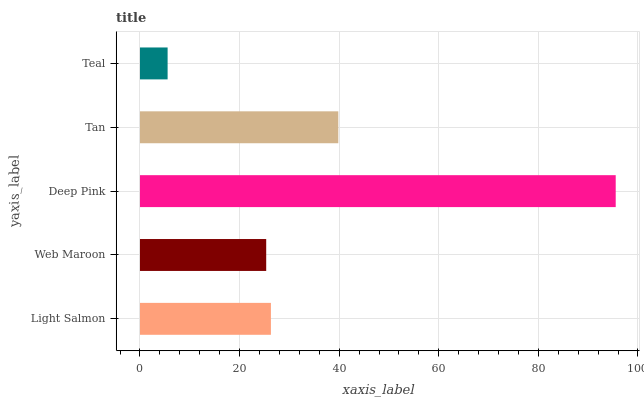Is Teal the minimum?
Answer yes or no. Yes. Is Deep Pink the maximum?
Answer yes or no. Yes. Is Web Maroon the minimum?
Answer yes or no. No. Is Web Maroon the maximum?
Answer yes or no. No. Is Light Salmon greater than Web Maroon?
Answer yes or no. Yes. Is Web Maroon less than Light Salmon?
Answer yes or no. Yes. Is Web Maroon greater than Light Salmon?
Answer yes or no. No. Is Light Salmon less than Web Maroon?
Answer yes or no. No. Is Light Salmon the high median?
Answer yes or no. Yes. Is Light Salmon the low median?
Answer yes or no. Yes. Is Web Maroon the high median?
Answer yes or no. No. Is Teal the low median?
Answer yes or no. No. 